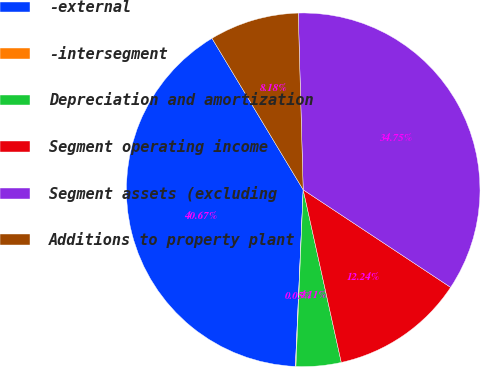<chart> <loc_0><loc_0><loc_500><loc_500><pie_chart><fcel>-external<fcel>-intersegment<fcel>Depreciation and amortization<fcel>Segment operating income<fcel>Segment assets (excluding<fcel>Additions to property plant<nl><fcel>40.67%<fcel>0.05%<fcel>4.11%<fcel>12.24%<fcel>34.75%<fcel>8.18%<nl></chart> 